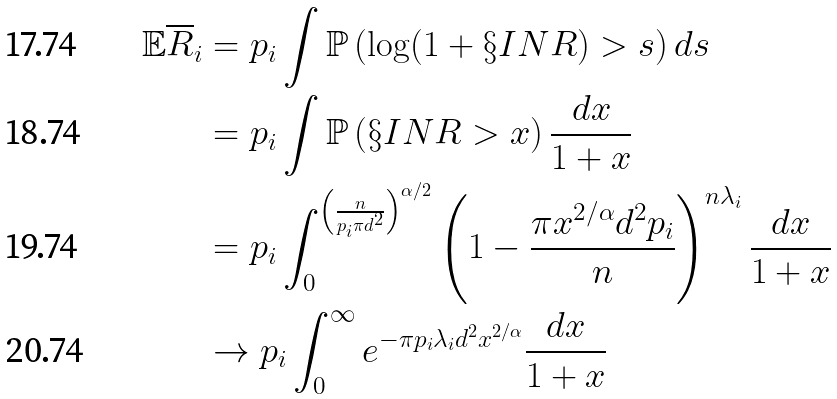<formula> <loc_0><loc_0><loc_500><loc_500>\mathbb { E } { \overline { R } } _ { i } & = p _ { i } \int { \mathbb { P } } \left ( \log ( 1 + { \S I N R } ) > s \right ) d s \\ & = p _ { i } \int { \mathbb { P } } \left ( { \S I N R } > x \right ) \frac { d x } { 1 + x } \\ & = p _ { i } \int _ { 0 } ^ { \left ( \frac { n } { p _ { i } \pi d ^ { 2 } } \right ) ^ { \alpha / 2 } } \left ( 1 - \frac { \pi x ^ { 2 / \alpha } d ^ { 2 } p _ { i } } { n } \right ) ^ { n \lambda _ { i } } \frac { d x } { 1 + x } \\ & \rightarrow p _ { i } \int _ { 0 } ^ { \infty } e ^ { - \pi p _ { i } \lambda _ { i } d ^ { 2 } x ^ { 2 / \alpha } } \frac { d x } { 1 + x }</formula> 